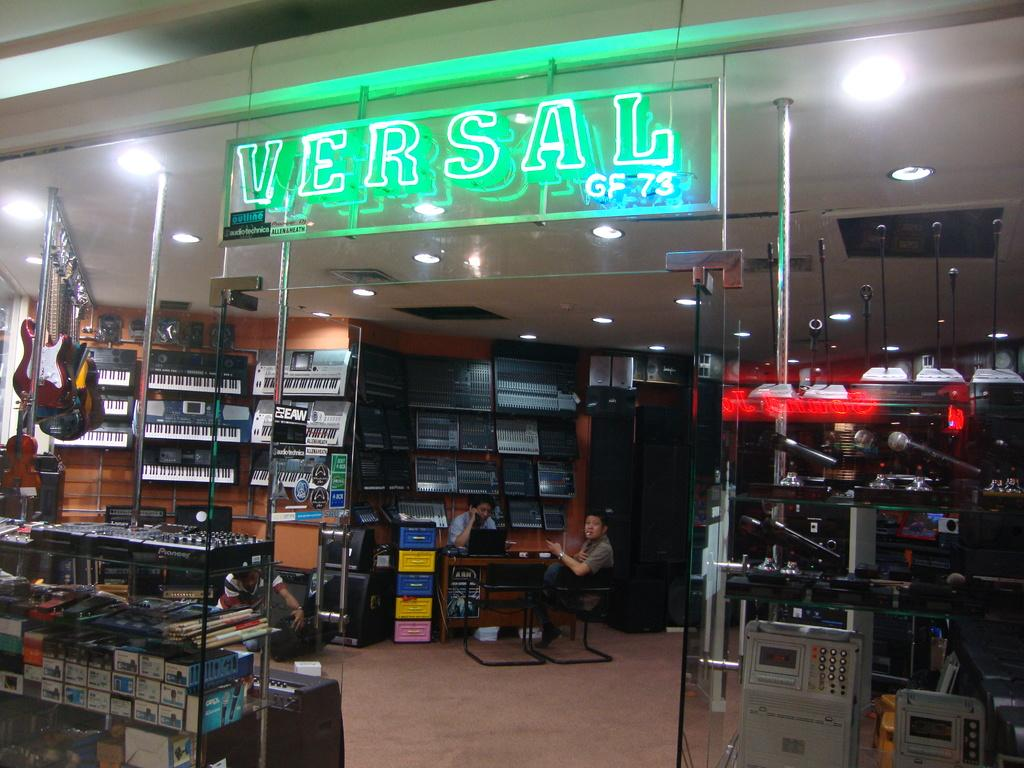Provide a one-sentence caption for the provided image. A music store called Versal displaying various musical instruments including keyboards. 